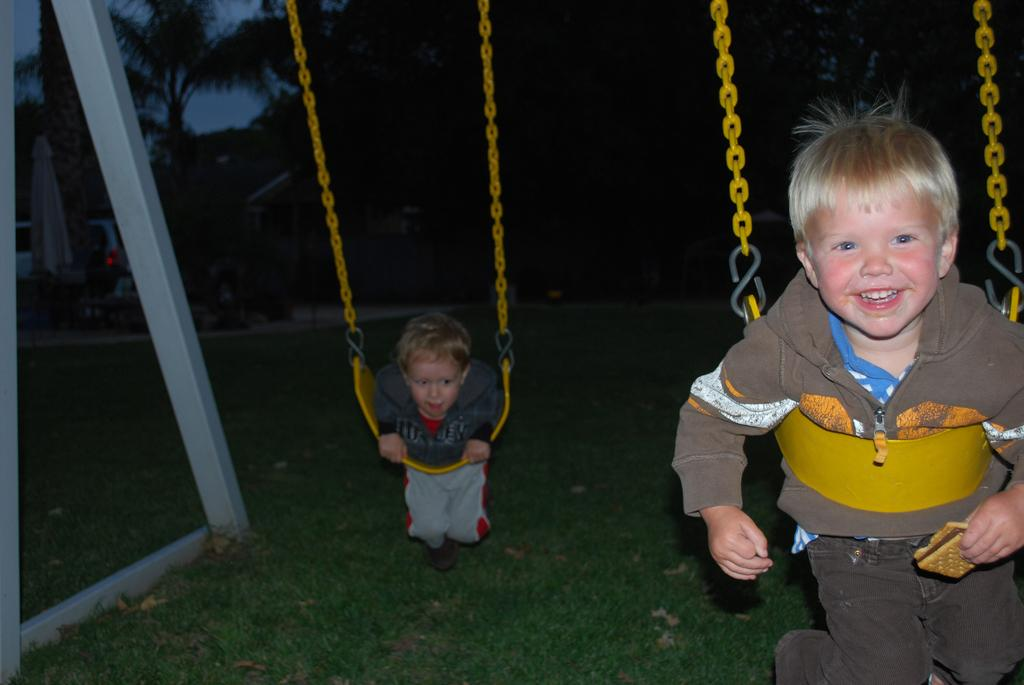How many children are in the image? There are two children in the image. What are the children doing in the image? The children are on swings. What color are the swings? The swings are yellow in color. What is on the ground beneath the swings? There is grass on the ground. What else can be seen in the image besides the children and swings? There is a vehicle and trees in the background, and the sky is visible in the background. How many fingers does the cart have in the image? There is no cart present in the image, so it is not possible to determine how many fingers it might have. 